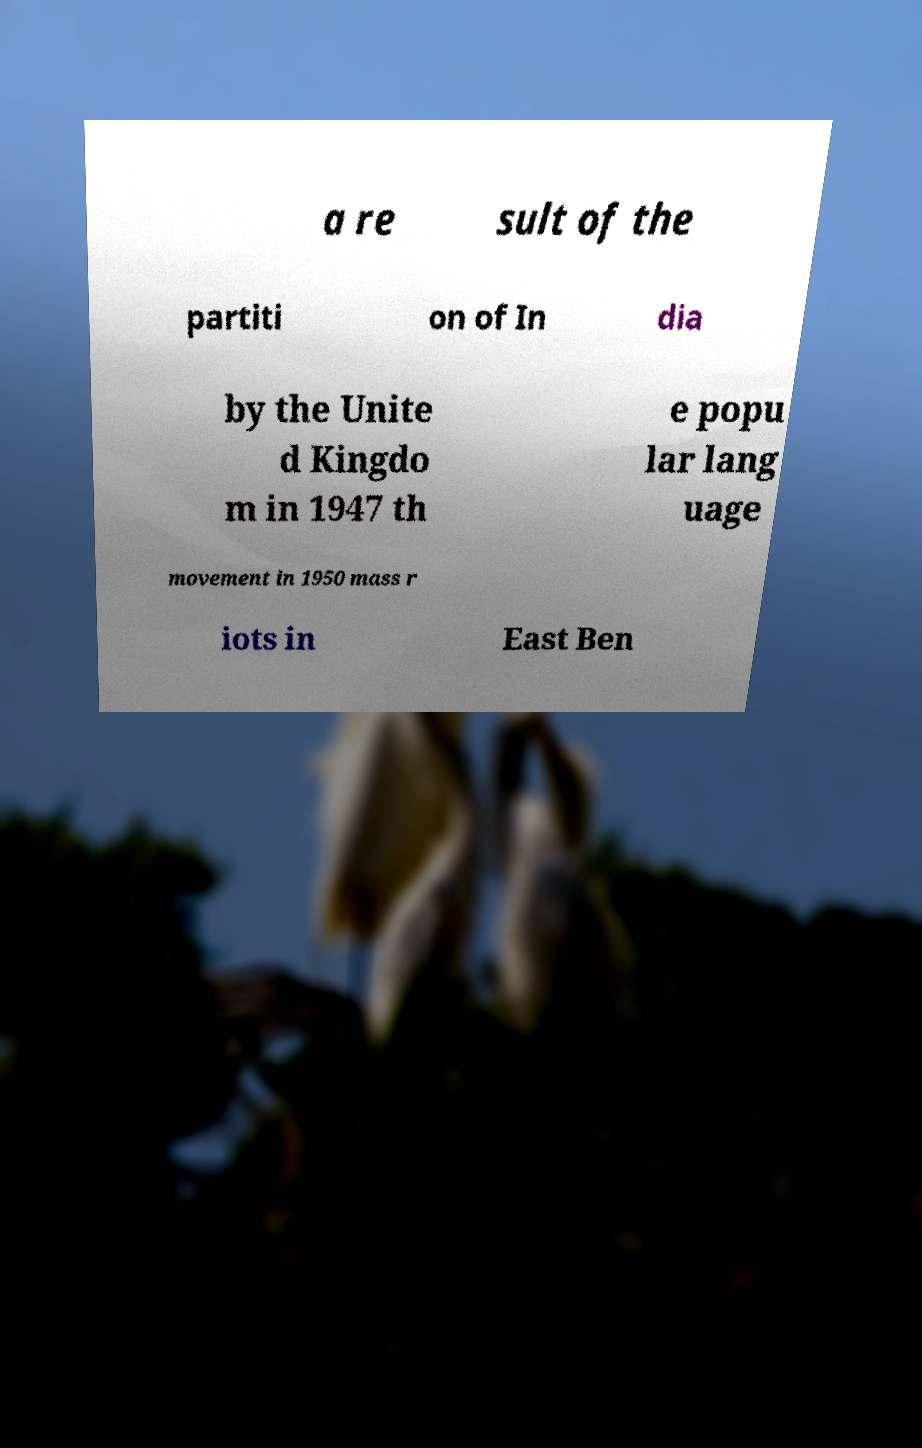I need the written content from this picture converted into text. Can you do that? a re sult of the partiti on of In dia by the Unite d Kingdo m in 1947 th e popu lar lang uage movement in 1950 mass r iots in East Ben 